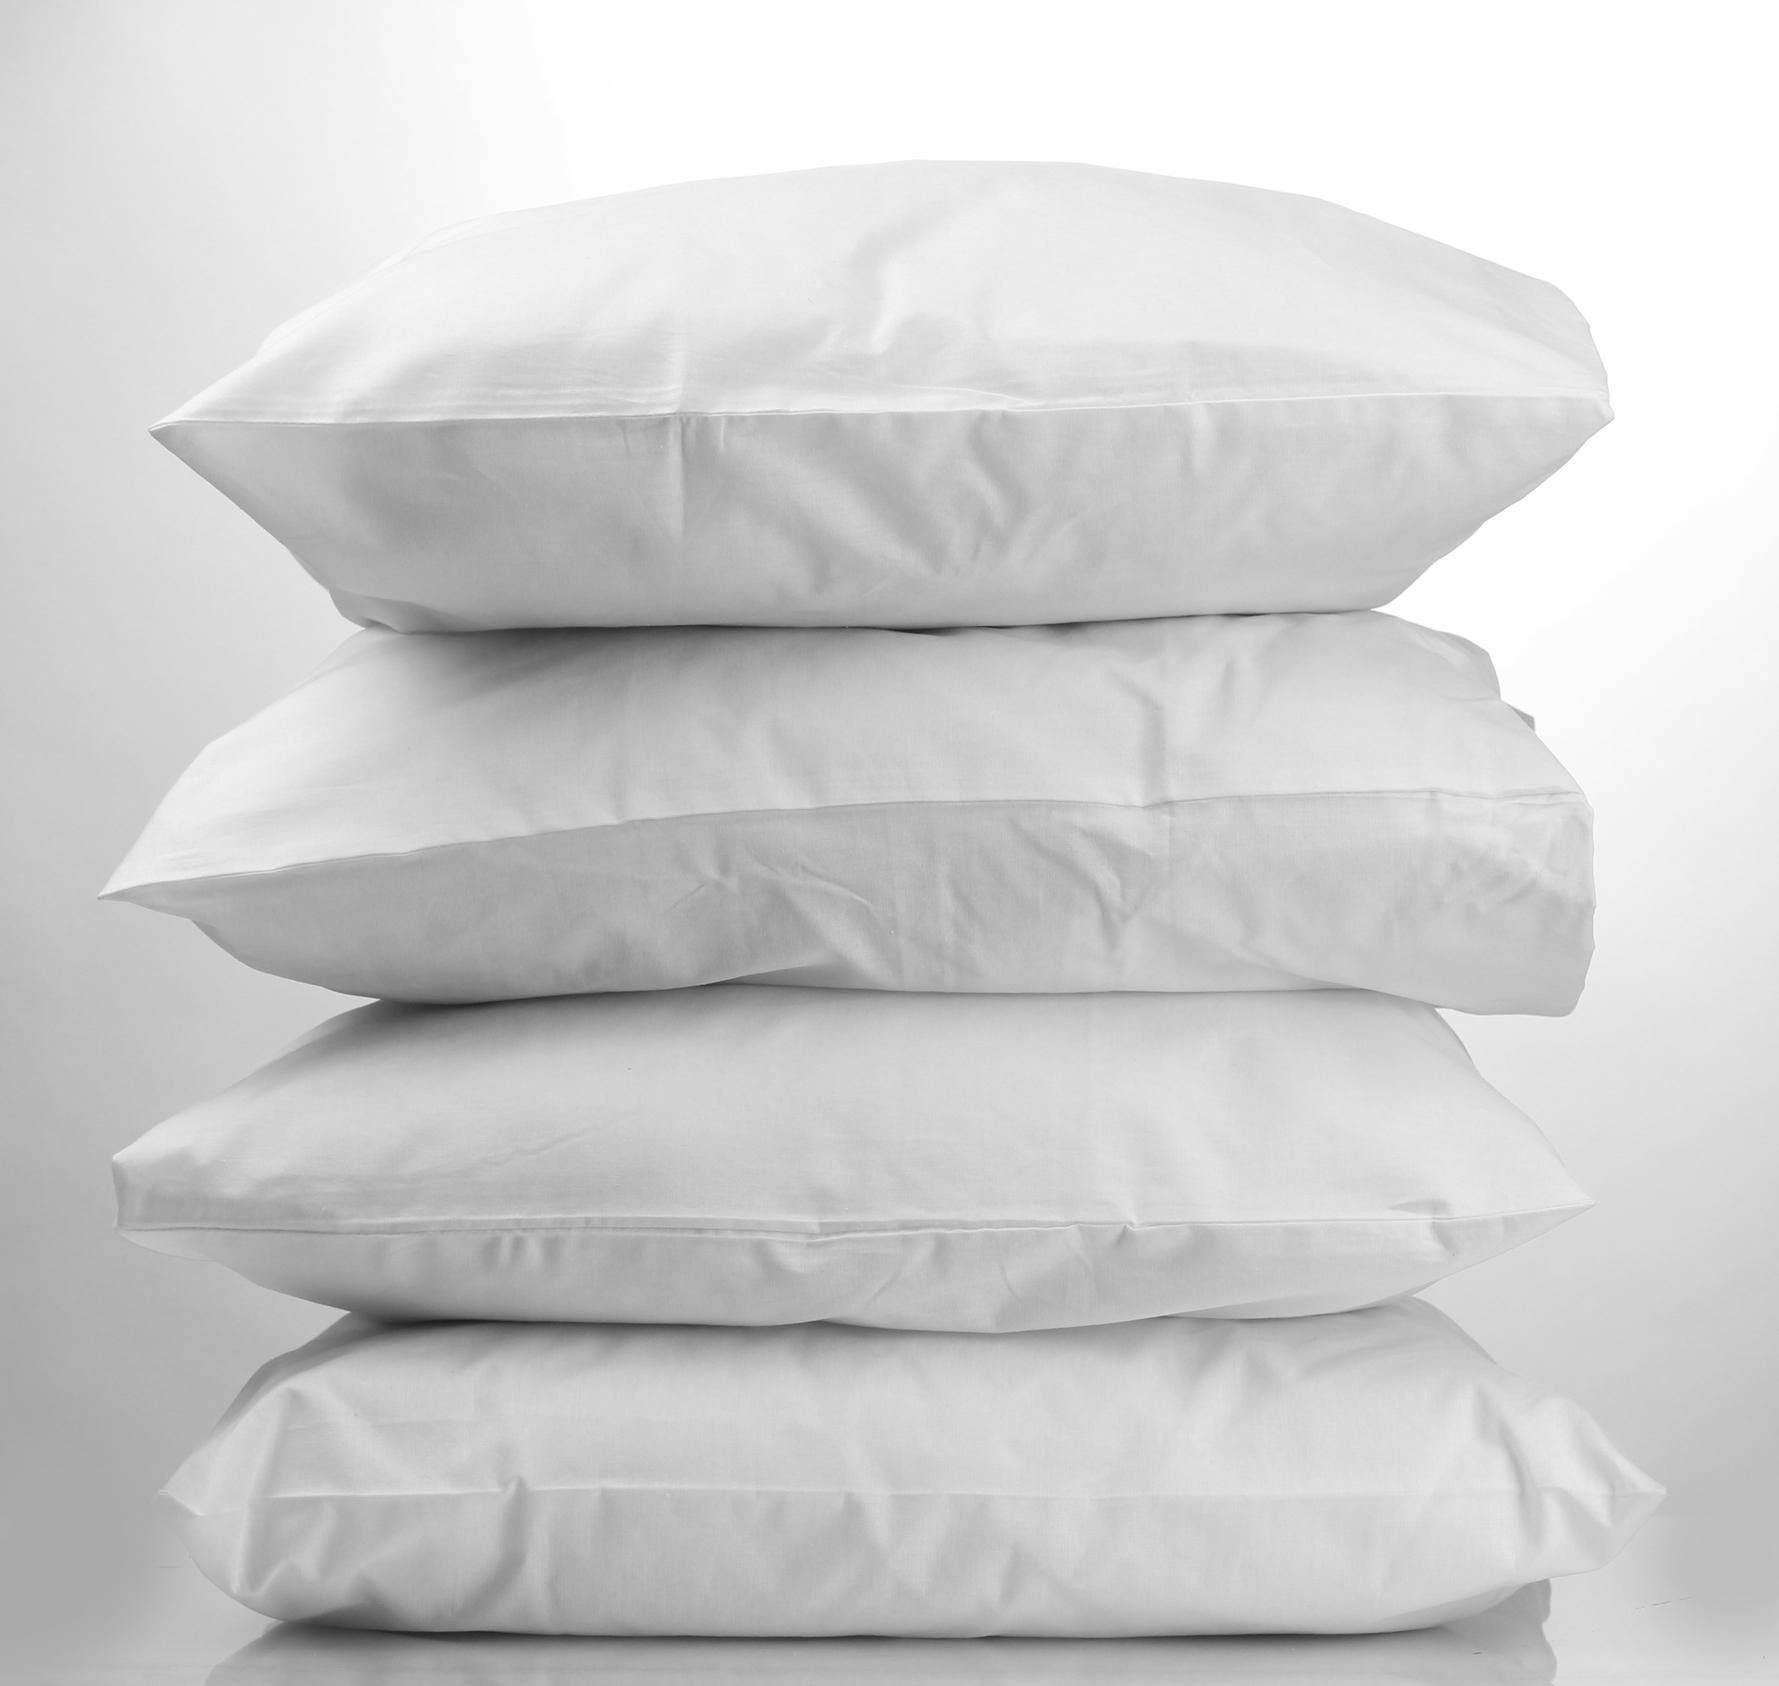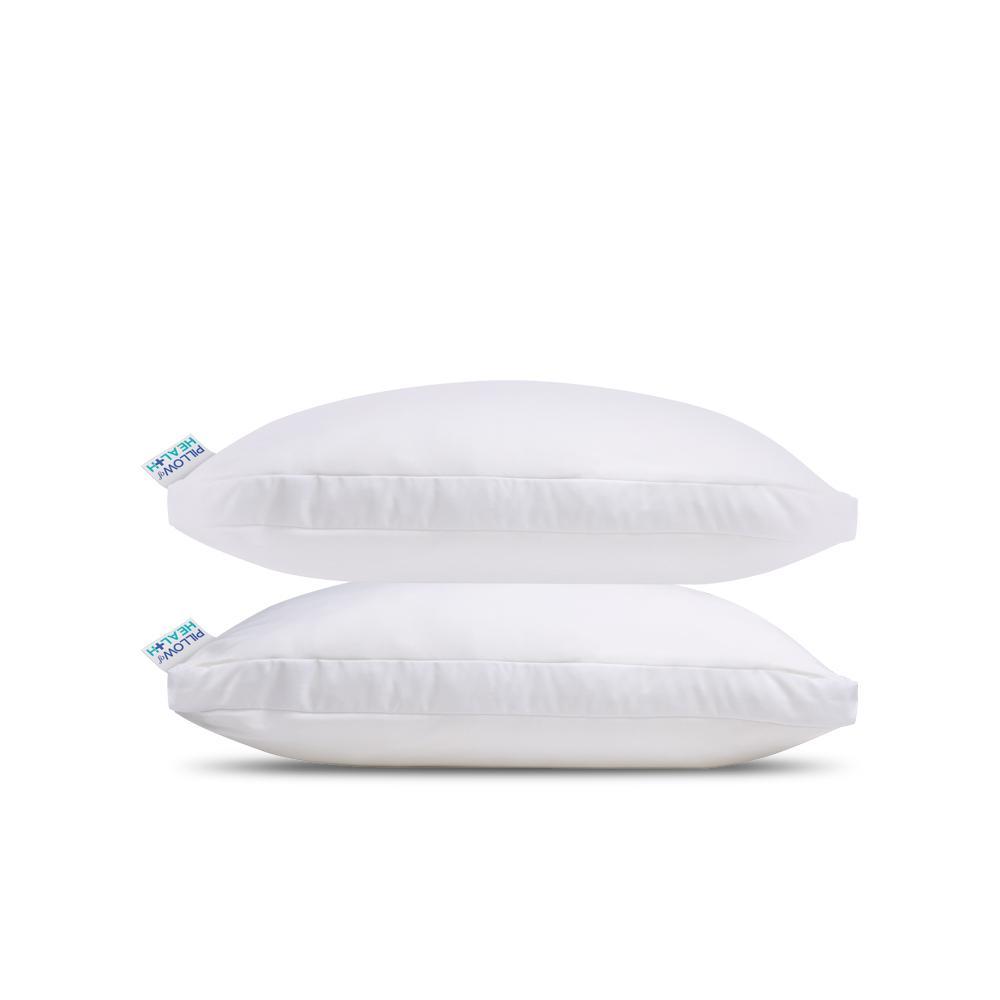The first image is the image on the left, the second image is the image on the right. For the images shown, is this caption "There are four pillows stacked up in the image on the left." true? Answer yes or no. Yes. 